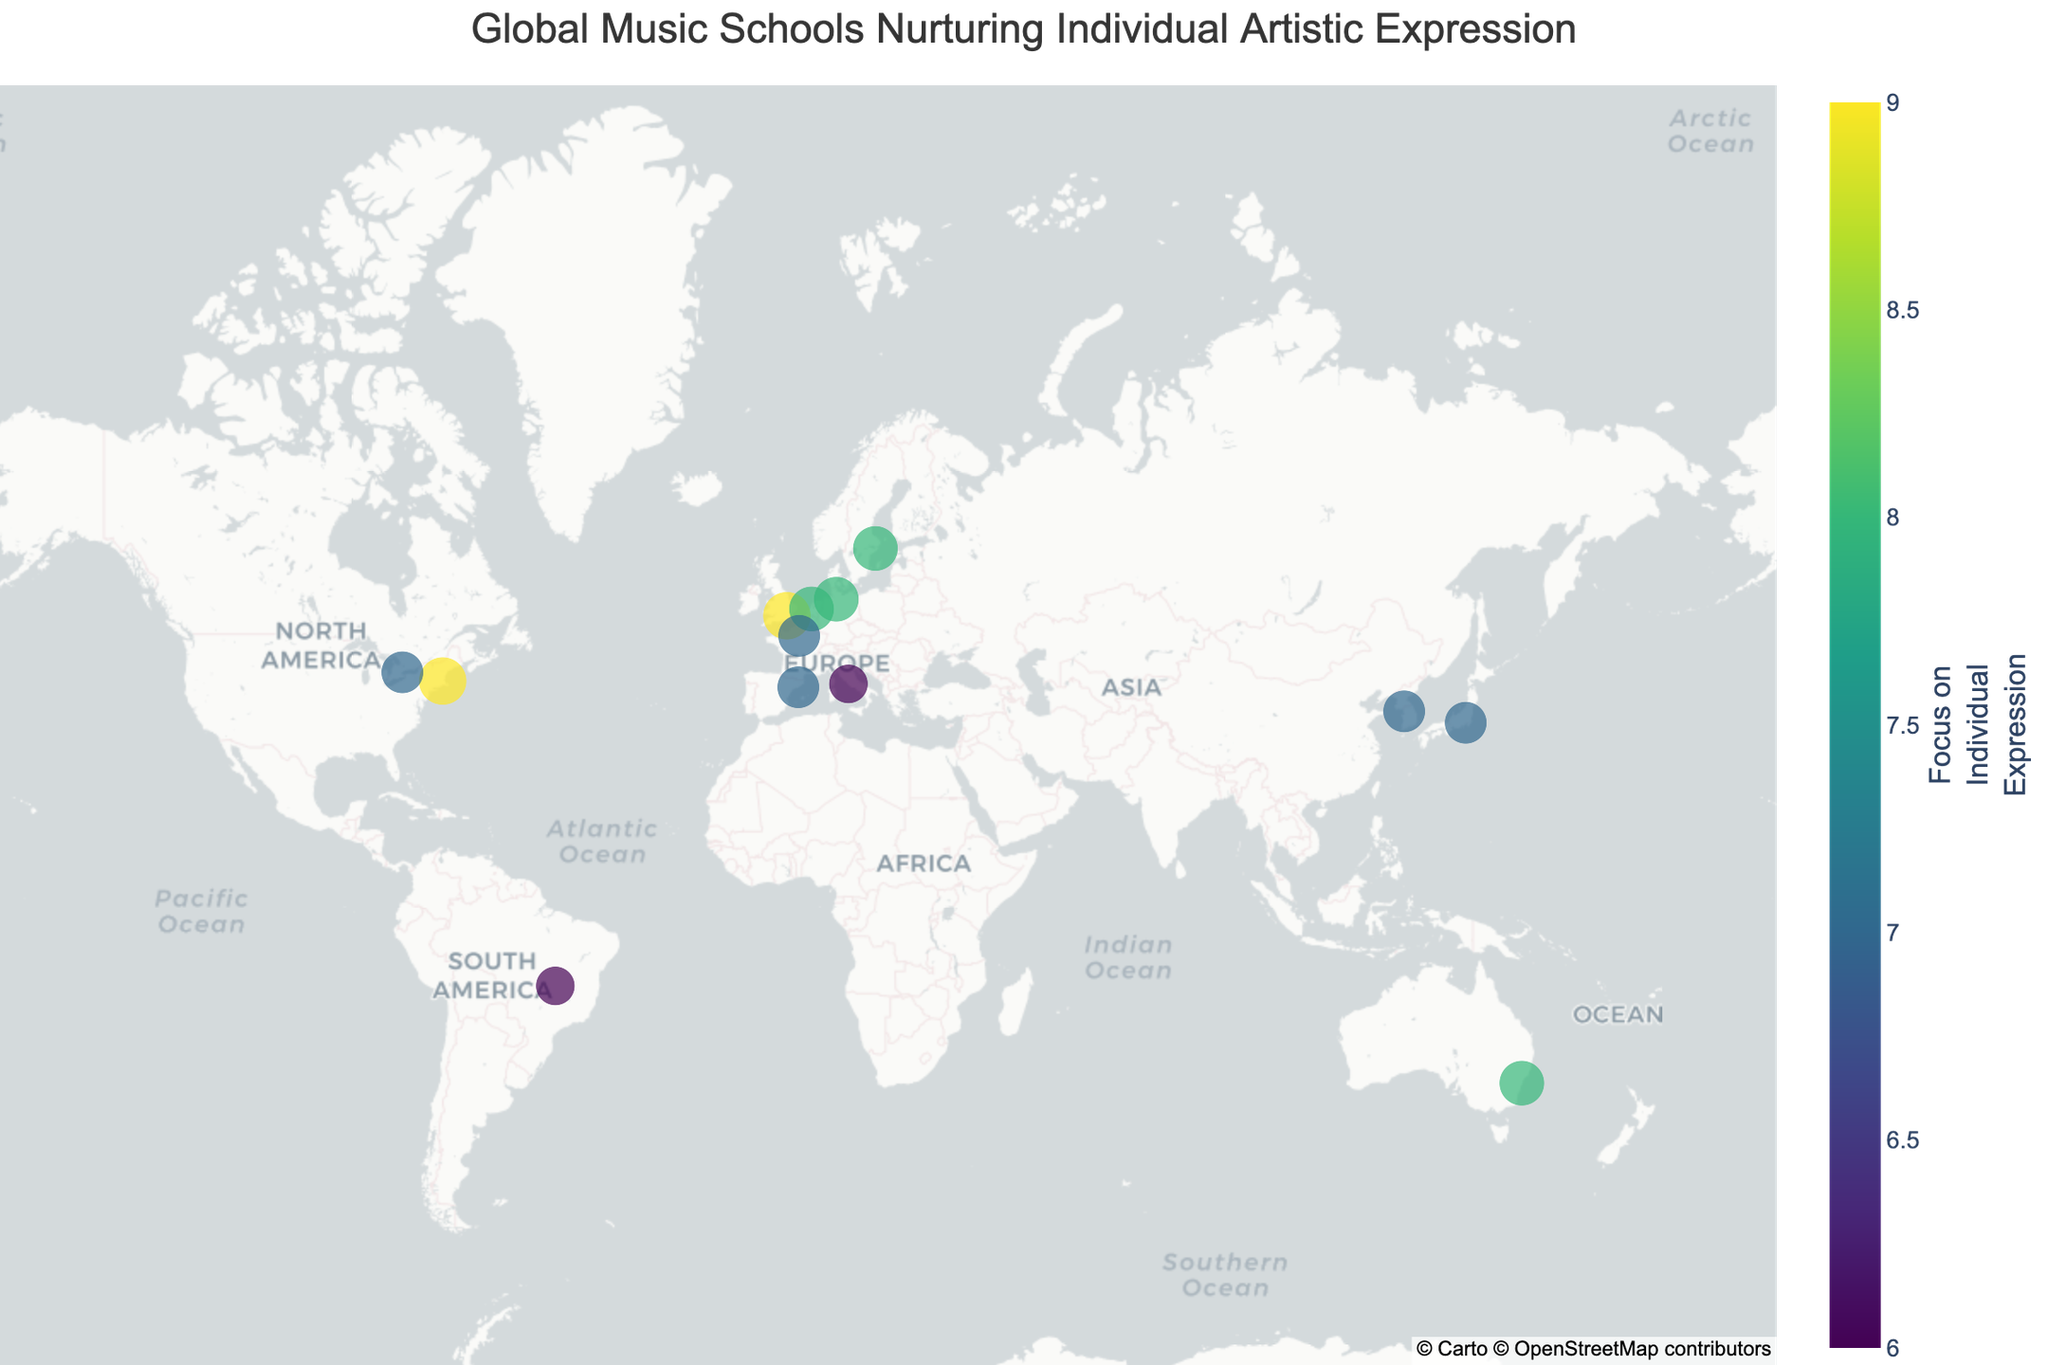What is the title of the plot? The title can be found at the top of the plot and usually summarizes what the plot is about.
Answer: Global Music Schools Nurturing Individual Artistic Expression Which music school has the highest focus on individual expression, and what is that rating? Look for the institution with the largest dot (representing the highest focus on individual expression) and check its rating in the hover data.
Answer: Berklee College of Music, 9 Which country has the most institutions listed on the plot? Count the number of data points corresponding to each country and see which country has the most.
Answer: USA What is the color scale used in the plot, and what does it represent? Observe the legend or color bar; it usually indicates the color scale and its meaning.
Answer: Viridis, representing Focus on Individual Expression How many institutions have a focus on individual expression rating of 7? Identify and count the data points that have a rating of 7 in their hover data.
Answer: 5 institutions Which institution is located farthest north? Look at the data points and identify the one with the highest latitude.
Answer: Royal College of Music Stockholm Compare the focus on individual expression rating between the Australian Institute of Music and the Conservatorium van Amsterdam. Use the hover data to compare the ratings of these two institutions directly.
Answer: Both have a rating of 8 What is the average focus on individual expression rating of all listed institutions? Add the ratings for all institutions and divide by the total number of institutions. Ratings: 9, 8, 7, 9, 8, 7, 8, 7, 8, 6, 7, 6, 7. Sum = 91. Average = 91/13
Answer: 7 Which two institutions have the closest geographic proximity based on their latitude and longitude? Compare the latitude and longitude values of institutions, and identify the pair with the smallest difference.
Answer: Escola Superior de Música de Catalunya and Conservatoire de Paris Between the Glenn Gould School and the Seoul Institute of the Arts, which one has a higher focus on individual expression rating? Review the hover data for both institutions to determine their respective ratings.
Answer: Seoul Institute of the Arts 